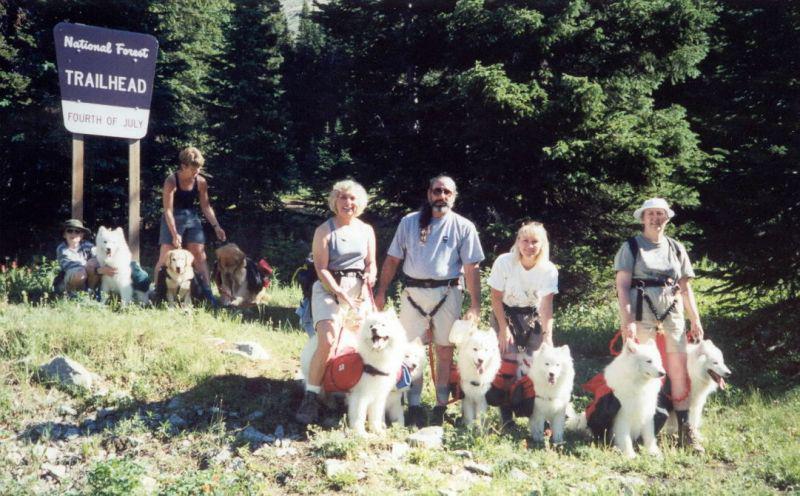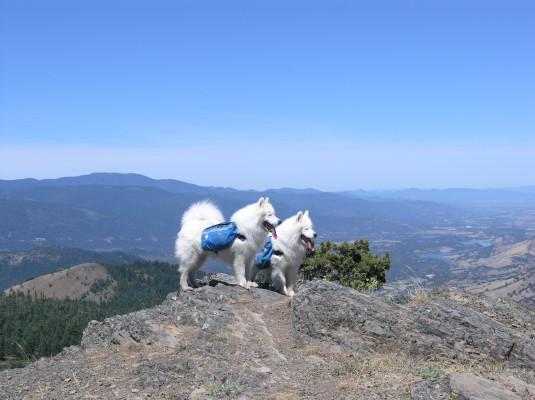The first image is the image on the left, the second image is the image on the right. Analyze the images presented: Is the assertion "White dogs are standing on a rocky edge." valid? Answer yes or no. Yes. The first image is the image on the left, the second image is the image on the right. Examine the images to the left and right. Is the description "AN image shows just one person posed behind one big white dog outdoors." accurate? Answer yes or no. No. 